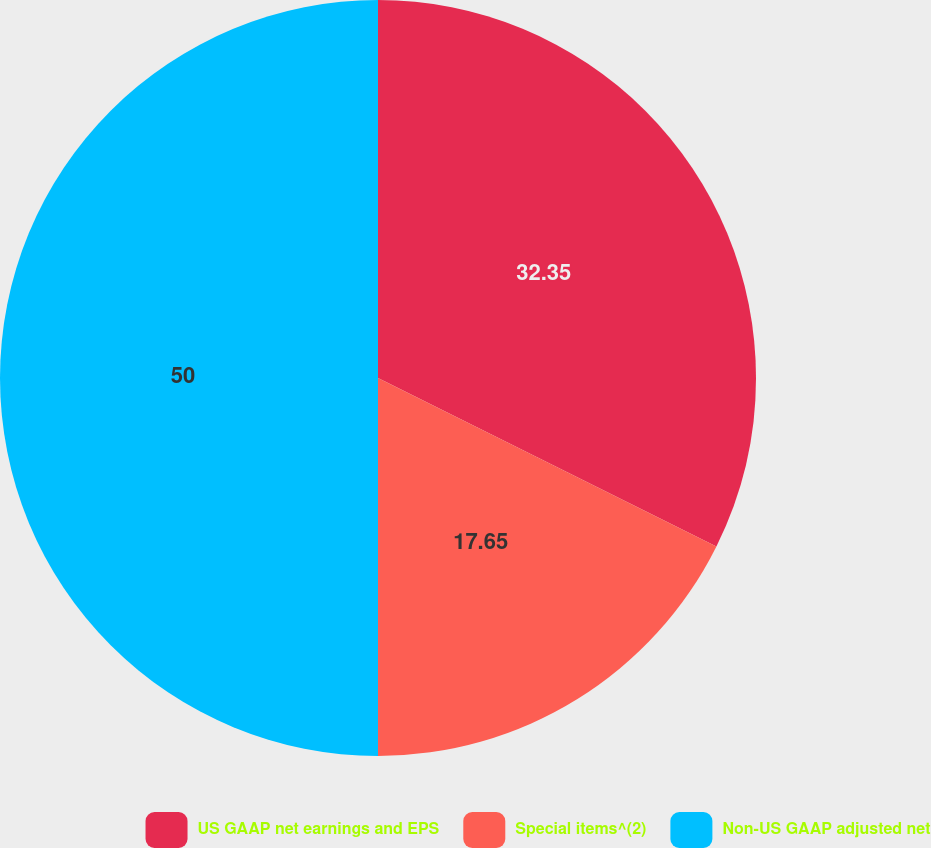Convert chart to OTSL. <chart><loc_0><loc_0><loc_500><loc_500><pie_chart><fcel>US GAAP net earnings and EPS<fcel>Special items^(2)<fcel>Non-US GAAP adjusted net<nl><fcel>32.35%<fcel>17.65%<fcel>50.0%<nl></chart> 